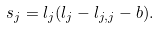Convert formula to latex. <formula><loc_0><loc_0><loc_500><loc_500>s _ { j } = l _ { j } ( l _ { j } - l _ { j , j } - b ) .</formula> 